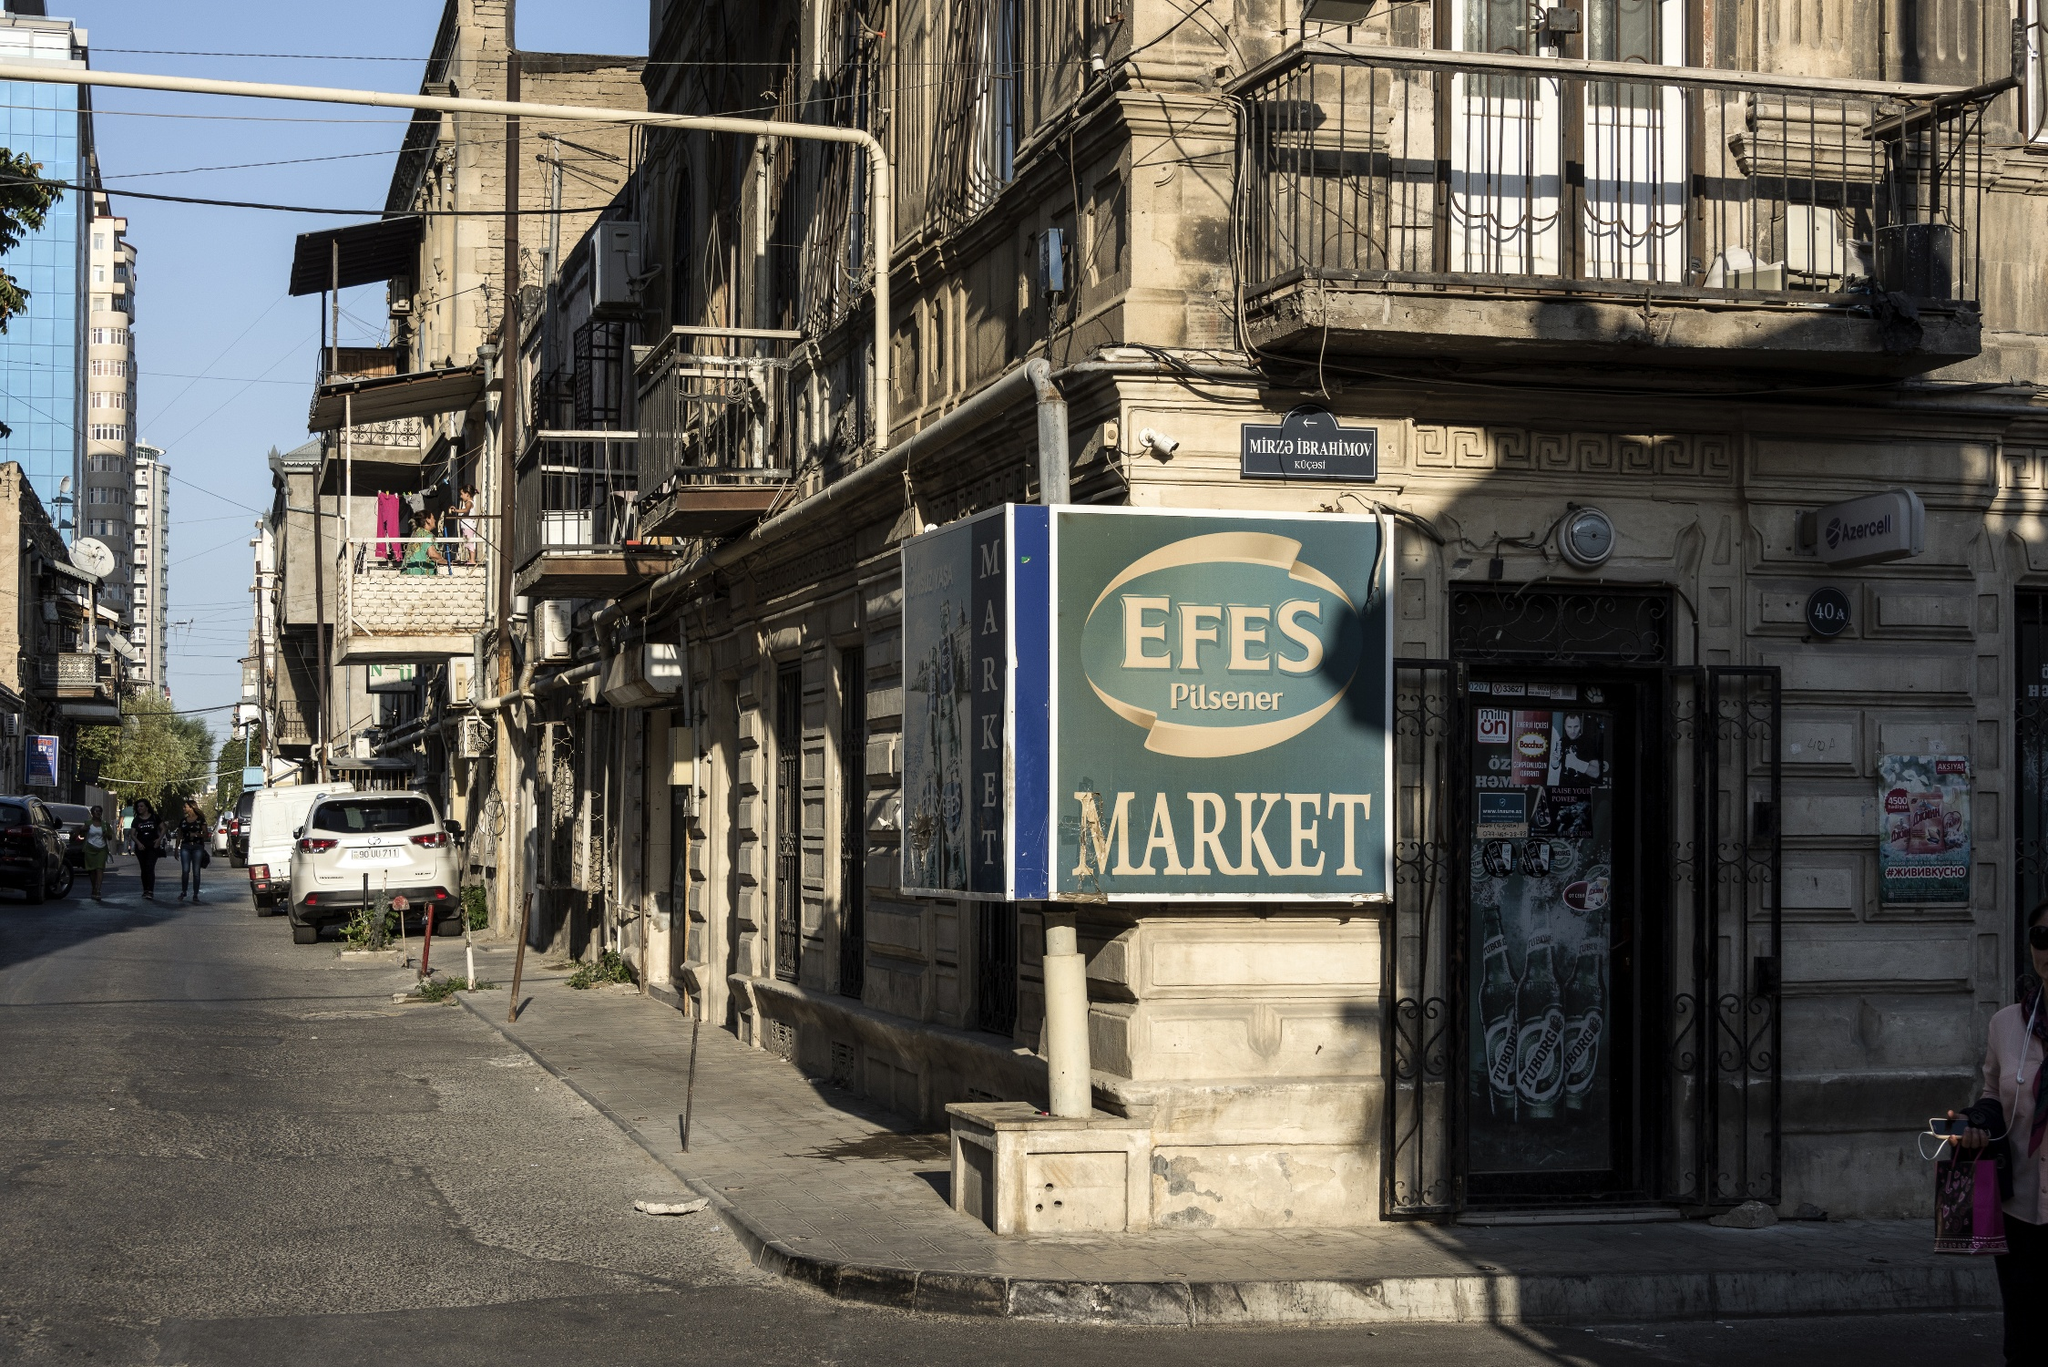Describe the market sign in detail. The market sign prominently reads "EFES Pilsener MARKET" in large, bold letters. The sign features a combination of blue and beige colors, with "EFES" and "Pilsener" displayed in an ornate, vintage font, while "MARKET" is in a simpler, yet equally bold typeface. The sign is mounted against a weathered stone wall, which adds to its retro charm. The contrast between the vibrant sign and the aged building behind it makes the market sign stand out, making it an unmistakable landmark on the street. 